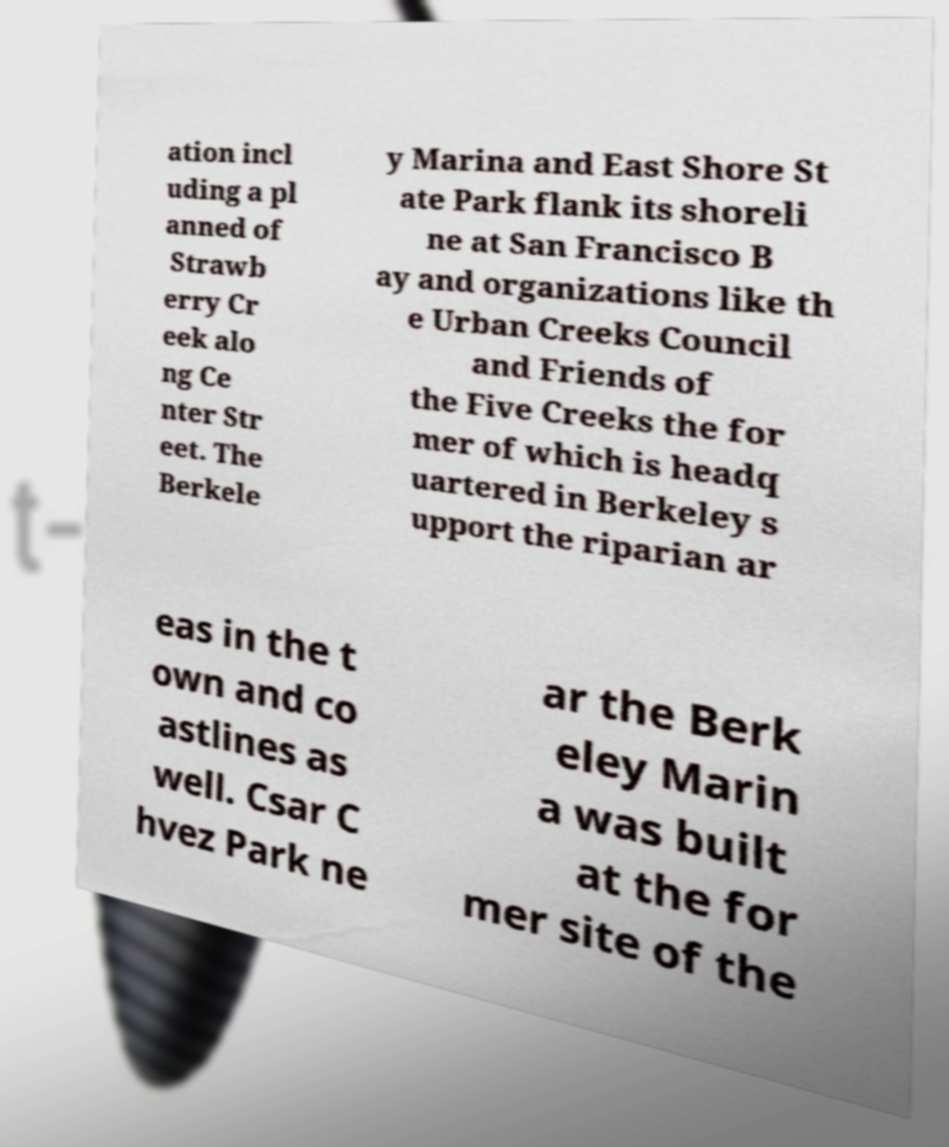What messages or text are displayed in this image? I need them in a readable, typed format. ation incl uding a pl anned of Strawb erry Cr eek alo ng Ce nter Str eet. The Berkele y Marina and East Shore St ate Park flank its shoreli ne at San Francisco B ay and organizations like th e Urban Creeks Council and Friends of the Five Creeks the for mer of which is headq uartered in Berkeley s upport the riparian ar eas in the t own and co astlines as well. Csar C hvez Park ne ar the Berk eley Marin a was built at the for mer site of the 